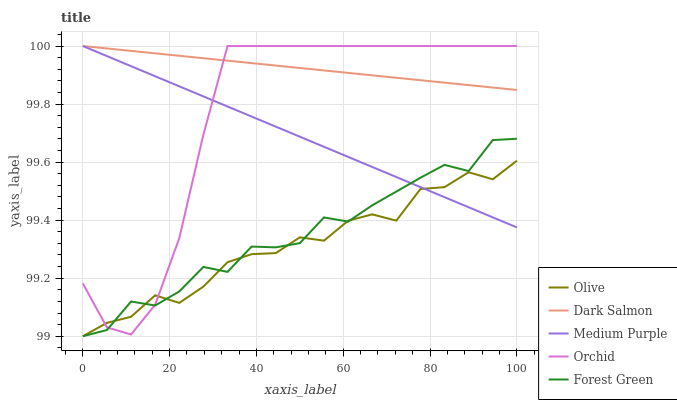Does Medium Purple have the minimum area under the curve?
Answer yes or no. No. Does Medium Purple have the maximum area under the curve?
Answer yes or no. No. Is Medium Purple the smoothest?
Answer yes or no. No. Is Medium Purple the roughest?
Answer yes or no. No. Does Medium Purple have the lowest value?
Answer yes or no. No. Does Forest Green have the highest value?
Answer yes or no. No. Is Forest Green less than Dark Salmon?
Answer yes or no. Yes. Is Dark Salmon greater than Forest Green?
Answer yes or no. Yes. Does Forest Green intersect Dark Salmon?
Answer yes or no. No. 